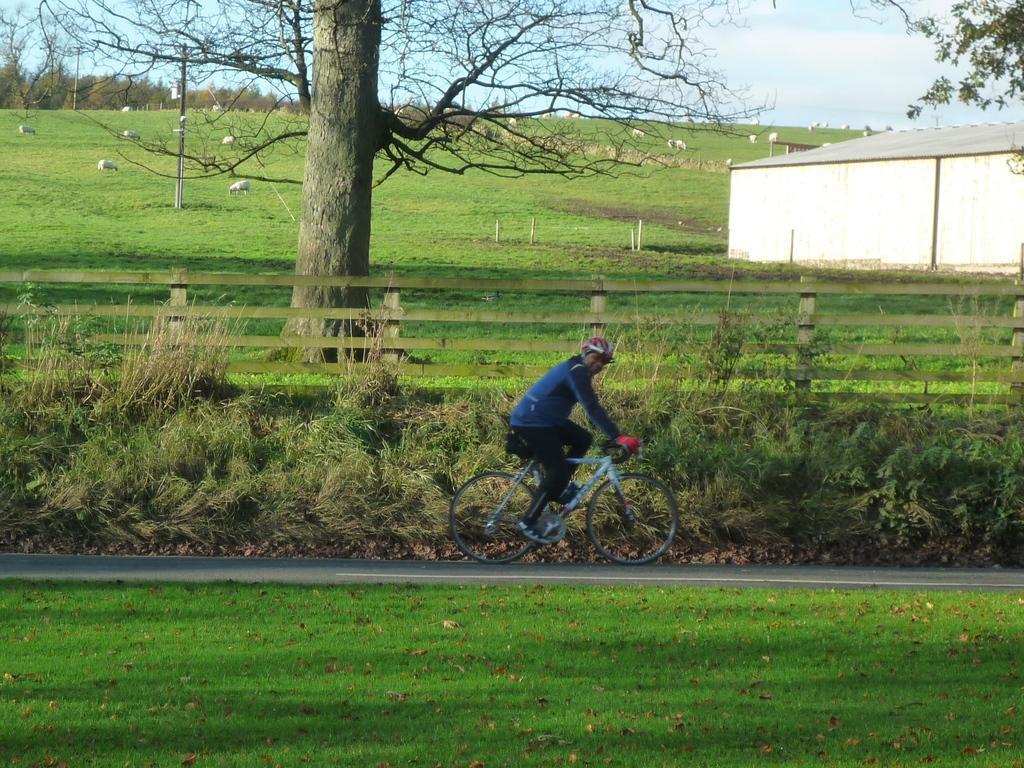Can you describe this image briefly? In the foreground of this image, at the bottom, there is grass land. In the middle, there is a man cycling on the road. Behind him, there is a wooden railing, tree, shelter, sheep, few poles, grassland and the sky. 